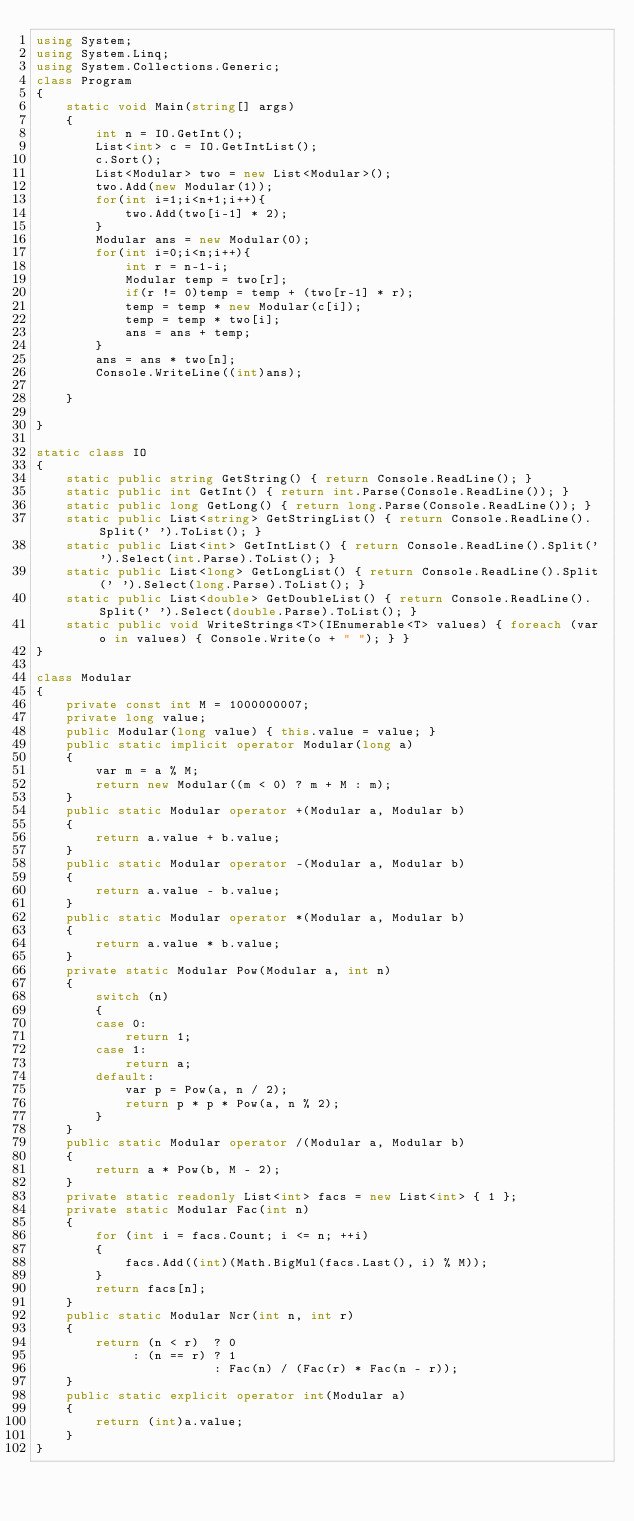Convert code to text. <code><loc_0><loc_0><loc_500><loc_500><_C#_>using System;
using System.Linq;
using System.Collections.Generic;
class Program
{
	static void Main(string[] args)
	{
	    int n = IO.GetInt();
	    List<int> c = IO.GetIntList();
	    c.Sort();
	    List<Modular> two = new List<Modular>();
	    two.Add(new Modular(1));
	    for(int i=1;i<n+1;i++){
	        two.Add(two[i-1] * 2);
	    }
	    Modular ans = new Modular(0);
	    for(int i=0;i<n;i++){
	        int r = n-1-i;
	        Modular temp = two[r];
	        if(r != 0)temp = temp + (two[r-1] * r);
	        temp = temp * new Modular(c[i]);
	        temp = temp * two[i];
	        ans = ans + temp;
	    }
	    ans = ans * two[n];
	    Console.WriteLine((int)ans);
	    
	}
    
}

static class IO
{
    static public string GetString() { return Console.ReadLine(); }
    static public int GetInt() { return int.Parse(Console.ReadLine()); }
    static public long GetLong() { return long.Parse(Console.ReadLine()); }
    static public List<string> GetStringList() { return Console.ReadLine().Split(' ').ToList(); }
    static public List<int> GetIntList() { return Console.ReadLine().Split(' ').Select(int.Parse).ToList(); }
    static public List<long> GetLongList() { return Console.ReadLine().Split(' ').Select(long.Parse).ToList(); }
    static public List<double> GetDoubleList() { return Console.ReadLine().Split(' ').Select(double.Parse).ToList(); }
    static public void WriteStrings<T>(IEnumerable<T> values) { foreach (var o in values) { Console.Write(o + " "); } }
}

class Modular
{
    private const int M = 1000000007;
    private long value;
    public Modular(long value) { this.value = value; }
    public static implicit operator Modular(long a)
    {
        var m = a % M;
        return new Modular((m < 0) ? m + M : m);
    }
    public static Modular operator +(Modular a, Modular b)
    {
        return a.value + b.value;
    }
    public static Modular operator -(Modular a, Modular b)
    {
        return a.value - b.value;
    }
    public static Modular operator *(Modular a, Modular b)
    {
        return a.value * b.value;
    }
    private static Modular Pow(Modular a, int n)
    {
        switch (n)
        {
        case 0:
            return 1;
        case 1:
            return a;
        default:
            var p = Pow(a, n / 2);
            return p * p * Pow(a, n % 2);
        }
    }
    public static Modular operator /(Modular a, Modular b)
    {
        return a * Pow(b, M - 2);
    }
    private static readonly List<int> facs = new List<int> { 1 };
    private static Modular Fac(int n)
    {
        for (int i = facs.Count; i <= n; ++i)
        {
            facs.Add((int)(Math.BigMul(facs.Last(), i) % M));
        }
        return facs[n];
    }
    public static Modular Ncr(int n, int r)
    {
        return (n < r)  ? 0
             : (n == r) ? 1
                        : Fac(n) / (Fac(r) * Fac(n - r));
    }
    public static explicit operator int(Modular a)
    {
        return (int)a.value;
    }
}</code> 